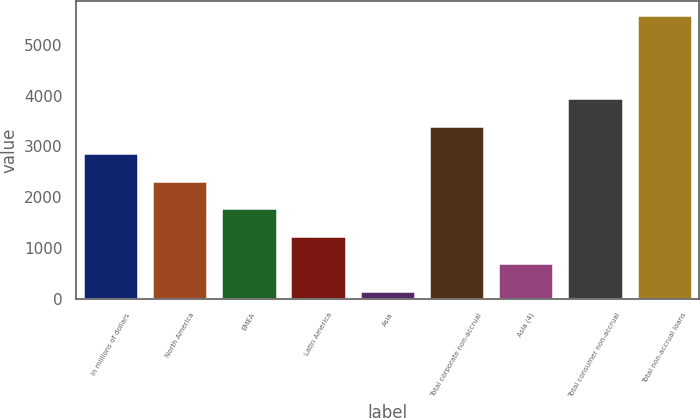Convert chart to OTSL. <chart><loc_0><loc_0><loc_500><loc_500><bar_chart><fcel>In millions of dollars<fcel>North America<fcel>EMEA<fcel>Latin America<fcel>Asia<fcel>Total corporate non-accrual<fcel>Asia (4)<fcel>Total consumer non-accrual<fcel>Total non-accrual loans<nl><fcel>2866.5<fcel>2324<fcel>1781.5<fcel>1239<fcel>154<fcel>3409<fcel>696.5<fcel>3951.5<fcel>5579<nl></chart> 